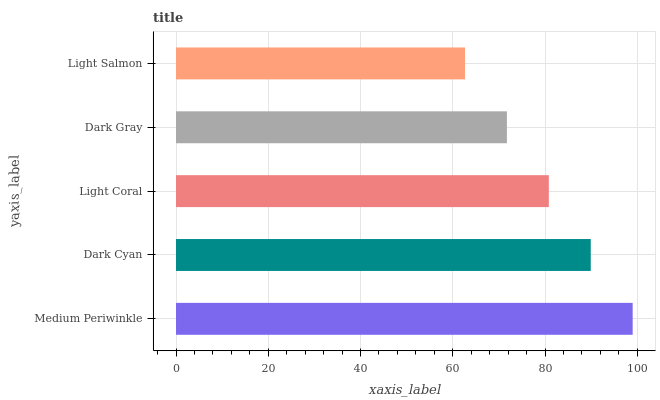Is Light Salmon the minimum?
Answer yes or no. Yes. Is Medium Periwinkle the maximum?
Answer yes or no. Yes. Is Dark Cyan the minimum?
Answer yes or no. No. Is Dark Cyan the maximum?
Answer yes or no. No. Is Medium Periwinkle greater than Dark Cyan?
Answer yes or no. Yes. Is Dark Cyan less than Medium Periwinkle?
Answer yes or no. Yes. Is Dark Cyan greater than Medium Periwinkle?
Answer yes or no. No. Is Medium Periwinkle less than Dark Cyan?
Answer yes or no. No. Is Light Coral the high median?
Answer yes or no. Yes. Is Light Coral the low median?
Answer yes or no. Yes. Is Dark Gray the high median?
Answer yes or no. No. Is Dark Cyan the low median?
Answer yes or no. No. 